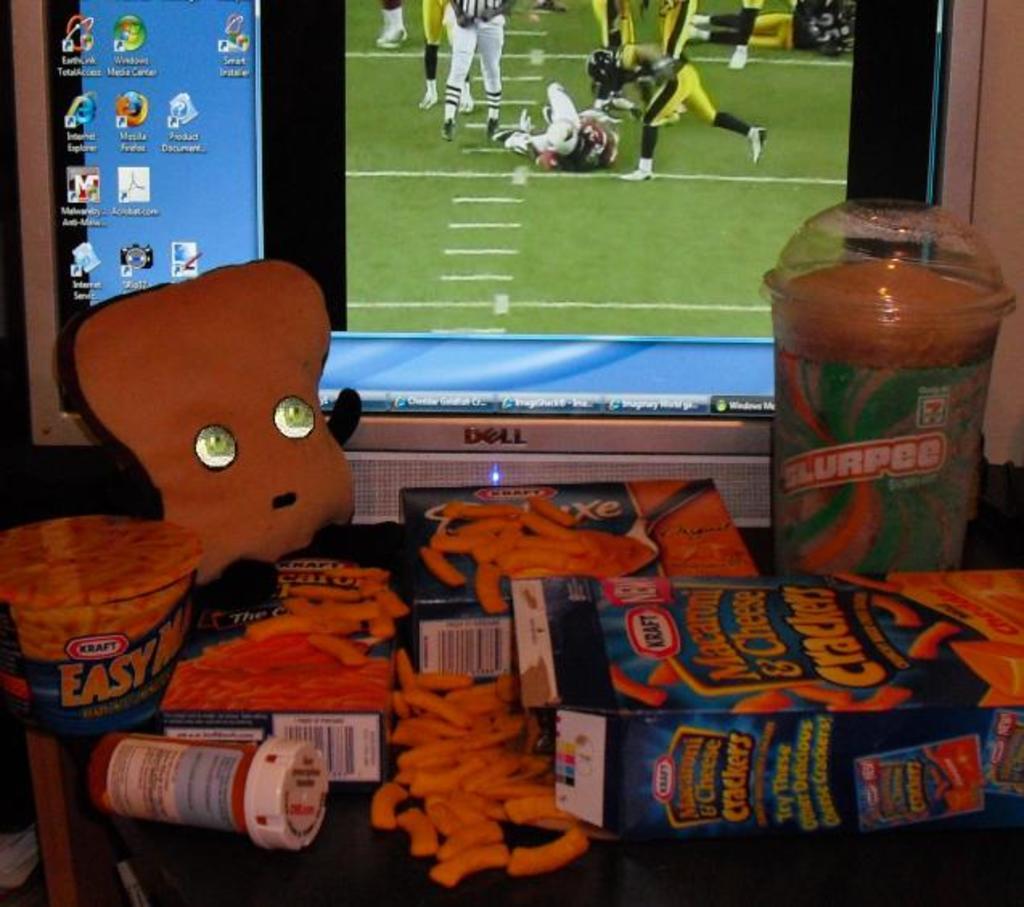What brand of macaroni and cheese is this?
Offer a terse response. Kraft. 